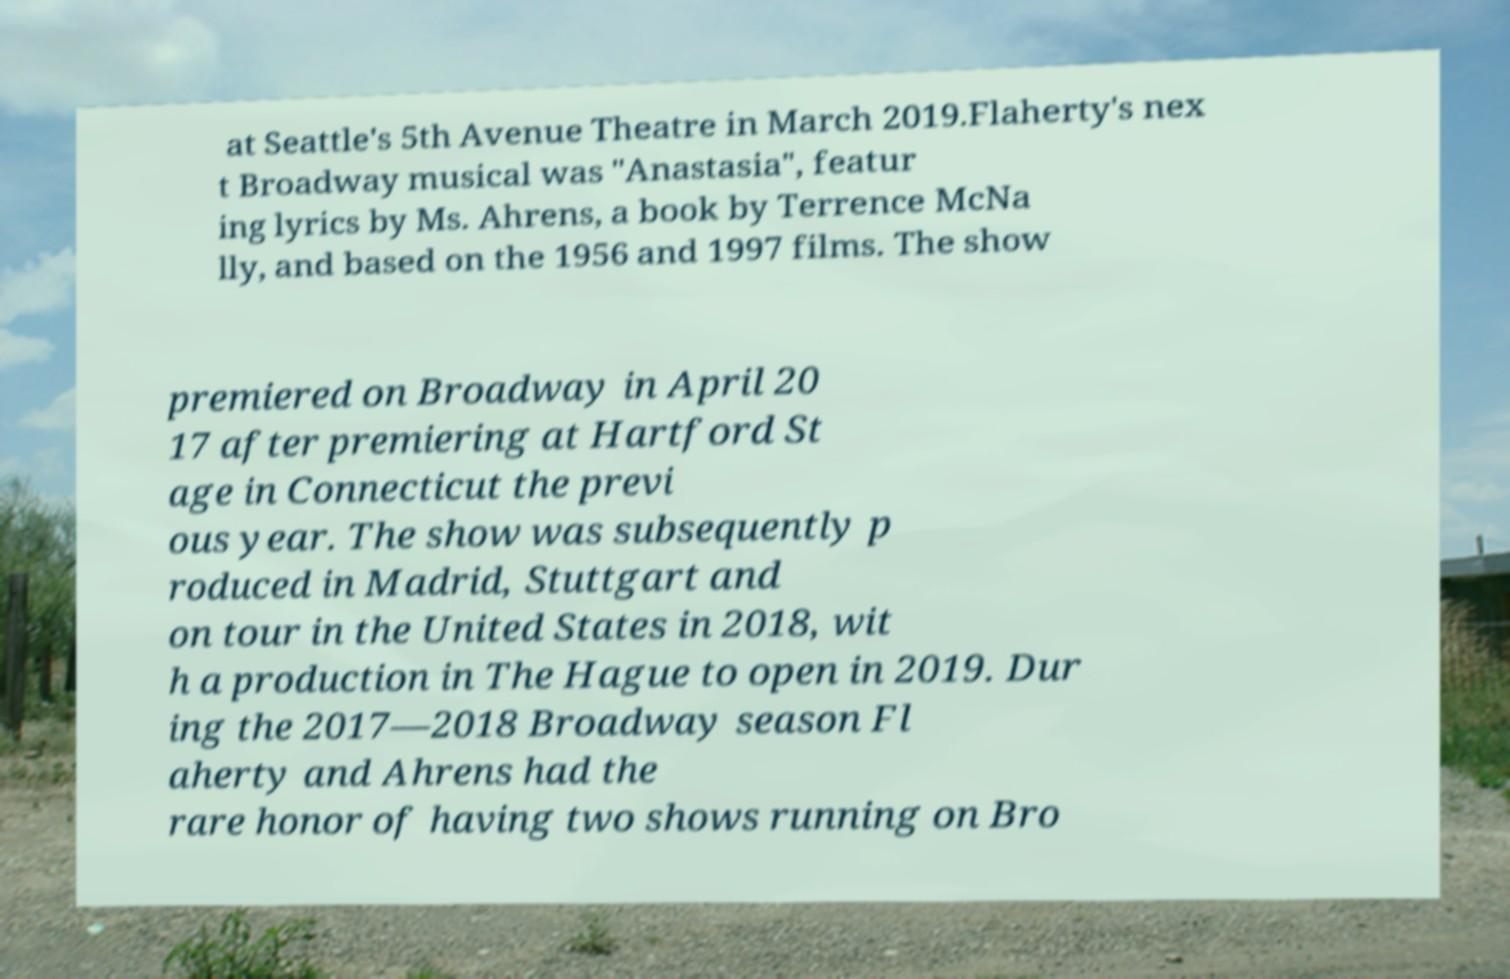There's text embedded in this image that I need extracted. Can you transcribe it verbatim? at Seattle's 5th Avenue Theatre in March 2019.Flaherty's nex t Broadway musical was "Anastasia", featur ing lyrics by Ms. Ahrens, a book by Terrence McNa lly, and based on the 1956 and 1997 films. The show premiered on Broadway in April 20 17 after premiering at Hartford St age in Connecticut the previ ous year. The show was subsequently p roduced in Madrid, Stuttgart and on tour in the United States in 2018, wit h a production in The Hague to open in 2019. Dur ing the 2017—2018 Broadway season Fl aherty and Ahrens had the rare honor of having two shows running on Bro 